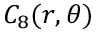Convert formula to latex. <formula><loc_0><loc_0><loc_500><loc_500>C _ { 8 } ( r , \theta )</formula> 